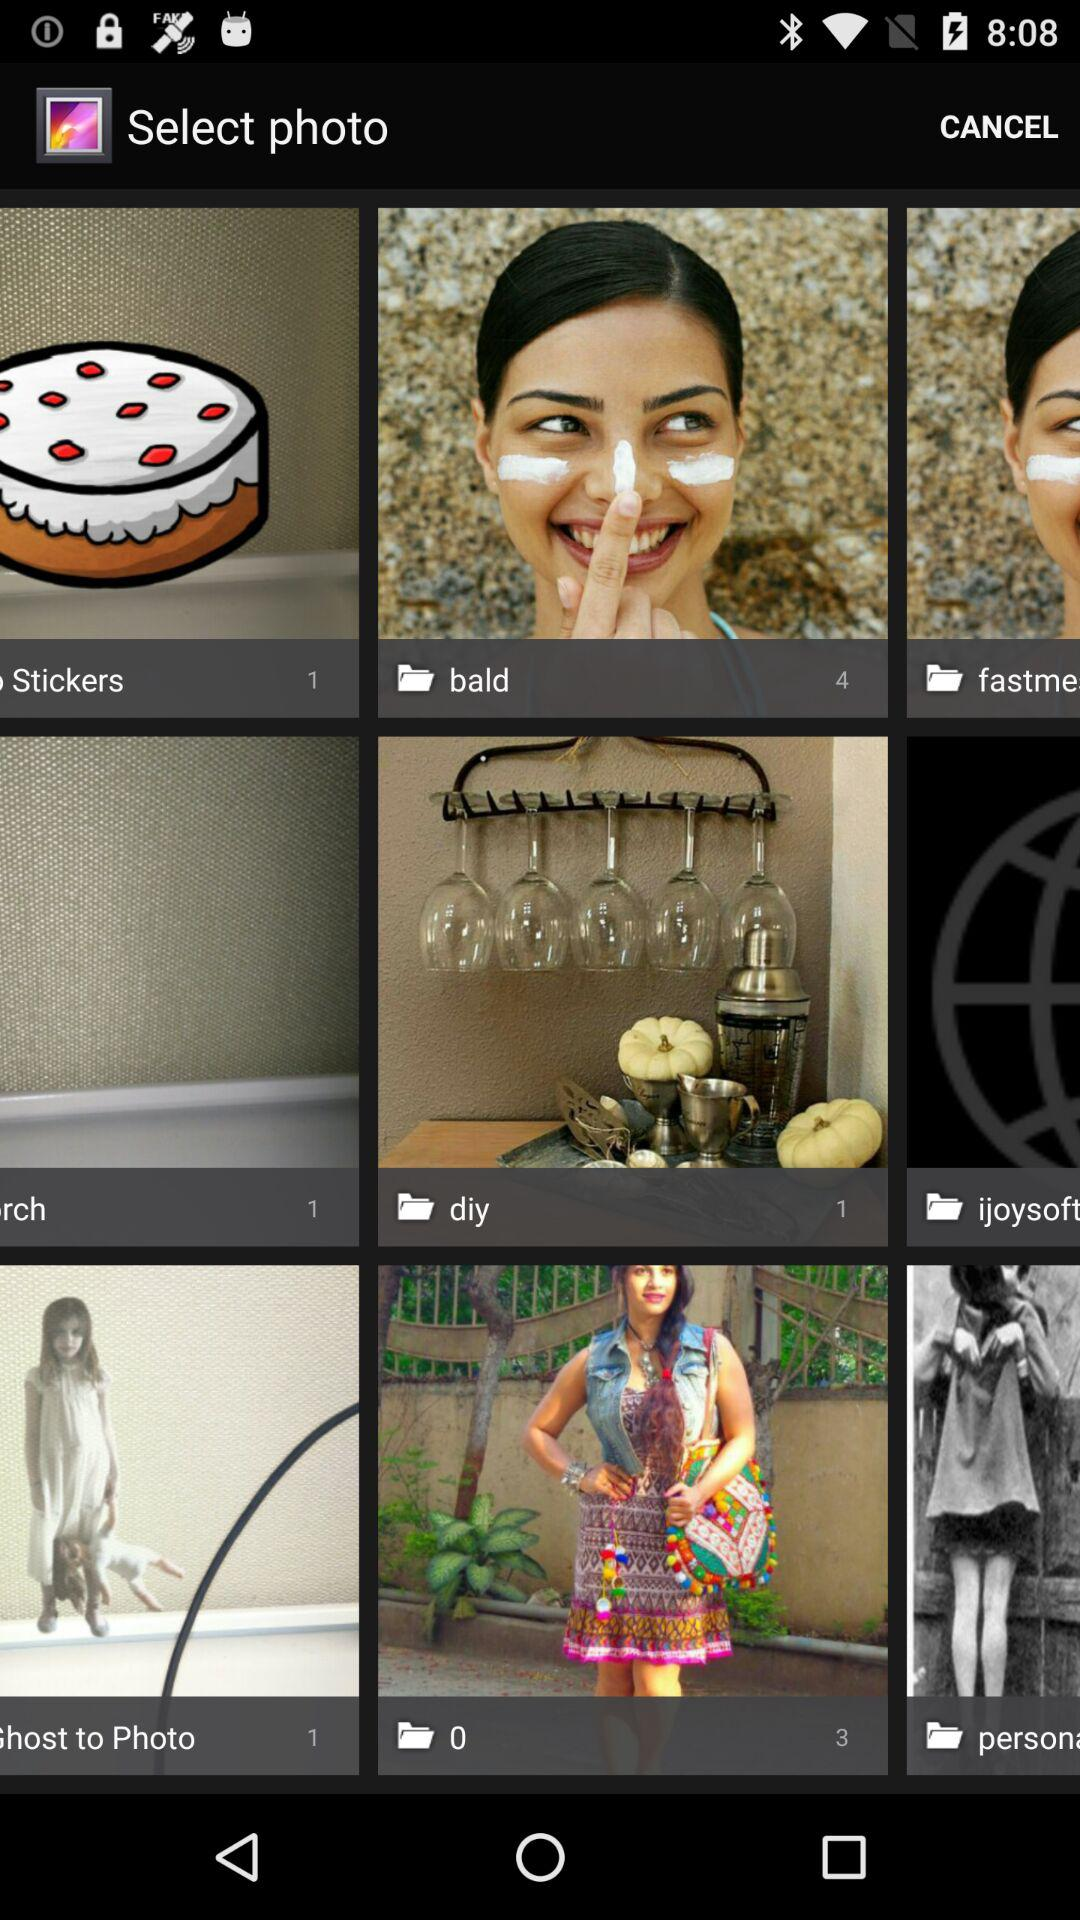What is the total number of photos in the "bald" folder? The total number of photos in the "bald" folder is 4. 